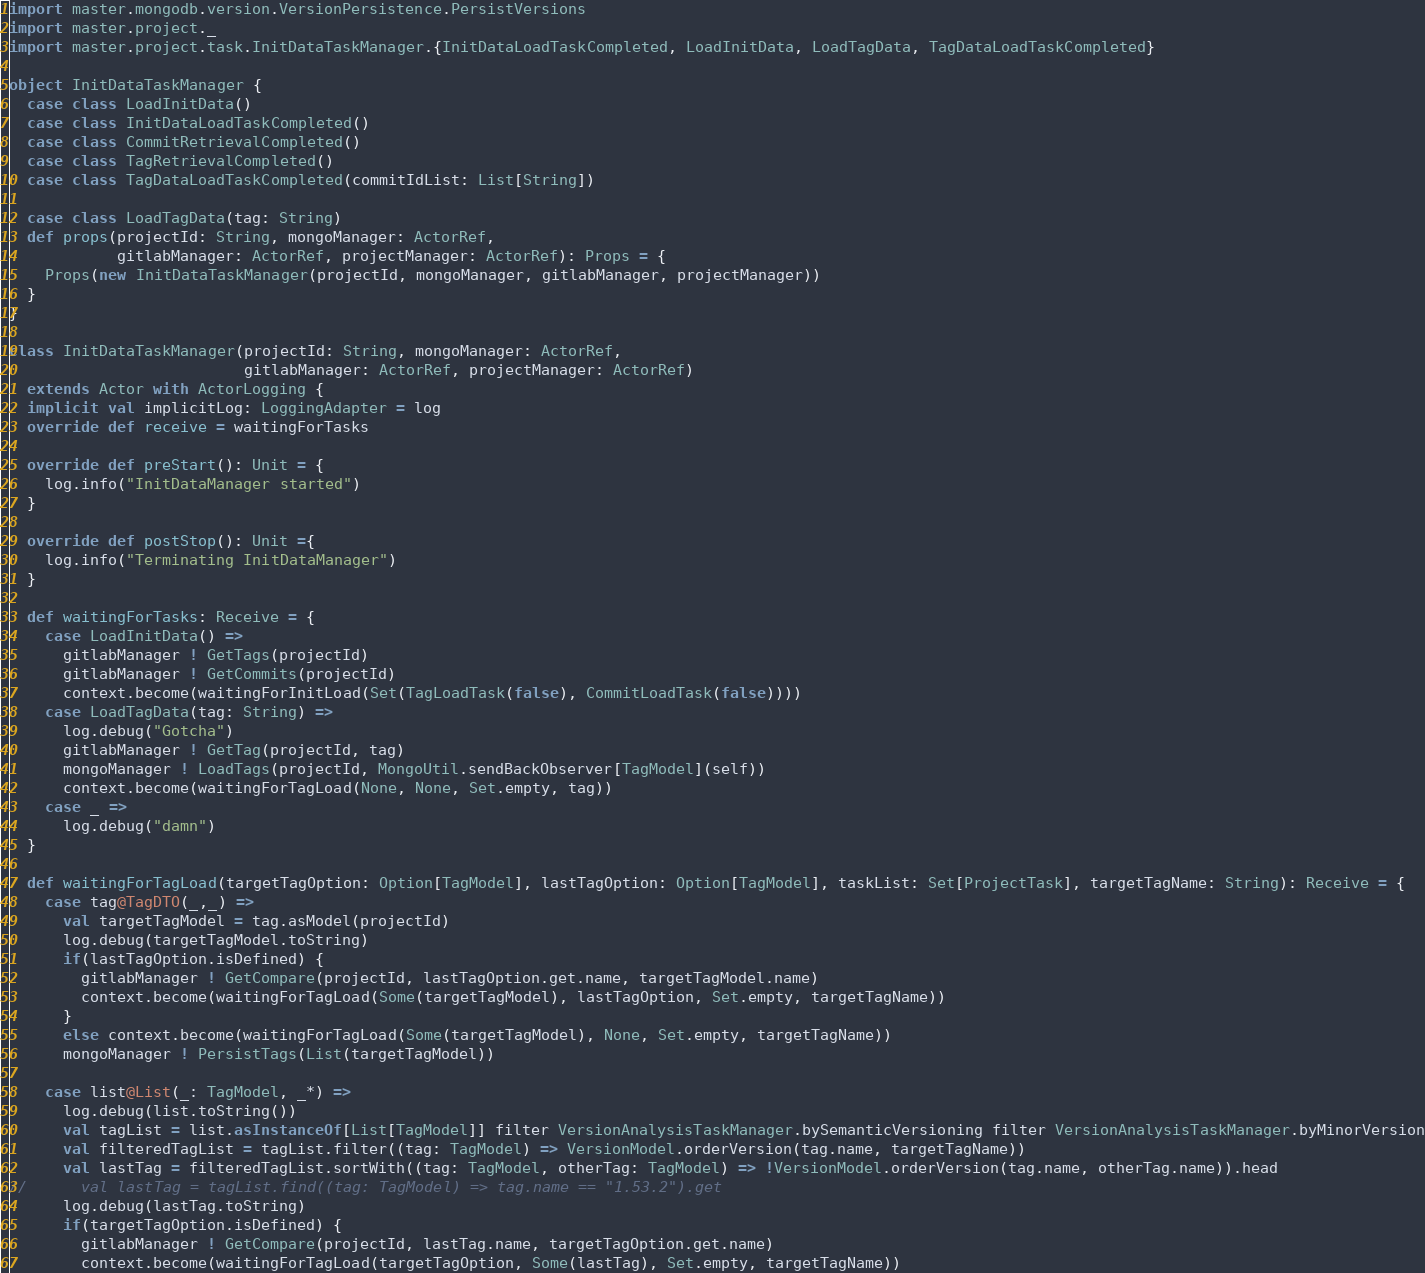Convert code to text. <code><loc_0><loc_0><loc_500><loc_500><_Scala_>import master.mongodb.version.VersionPersistence.PersistVersions
import master.project._
import master.project.task.InitDataTaskManager.{InitDataLoadTaskCompleted, LoadInitData, LoadTagData, TagDataLoadTaskCompleted}

object InitDataTaskManager {
  case class LoadInitData()
  case class InitDataLoadTaskCompleted()
  case class CommitRetrievalCompleted()
  case class TagRetrievalCompleted()
  case class TagDataLoadTaskCompleted(commitIdList: List[String])

  case class LoadTagData(tag: String)
  def props(projectId: String, mongoManager: ActorRef,
            gitlabManager: ActorRef, projectManager: ActorRef): Props = {
    Props(new InitDataTaskManager(projectId, mongoManager, gitlabManager, projectManager))
  }
}

class InitDataTaskManager(projectId: String, mongoManager: ActorRef,
                          gitlabManager: ActorRef, projectManager: ActorRef)
  extends Actor with ActorLogging {
  implicit val implicitLog: LoggingAdapter = log
  override def receive = waitingForTasks

  override def preStart(): Unit = {
    log.info("InitDataManager started")
  }

  override def postStop(): Unit ={
    log.info("Terminating InitDataManager")
  }

  def waitingForTasks: Receive = {
    case LoadInitData() =>
      gitlabManager ! GetTags(projectId)
      gitlabManager ! GetCommits(projectId)
      context.become(waitingForInitLoad(Set(TagLoadTask(false), CommitLoadTask(false))))
    case LoadTagData(tag: String) =>
      log.debug("Gotcha")
      gitlabManager ! GetTag(projectId, tag)
      mongoManager ! LoadTags(projectId, MongoUtil.sendBackObserver[TagModel](self))
      context.become(waitingForTagLoad(None, None, Set.empty, tag))
    case _ =>
      log.debug("damn")
  }

  def waitingForTagLoad(targetTagOption: Option[TagModel], lastTagOption: Option[TagModel], taskList: Set[ProjectTask], targetTagName: String): Receive = {
    case tag@TagDTO(_,_) =>
      val targetTagModel = tag.asModel(projectId)
      log.debug(targetTagModel.toString)
      if(lastTagOption.isDefined) {
        gitlabManager ! GetCompare(projectId, lastTagOption.get.name, targetTagModel.name)
        context.become(waitingForTagLoad(Some(targetTagModel), lastTagOption, Set.empty, targetTagName))
      }
      else context.become(waitingForTagLoad(Some(targetTagModel), None, Set.empty, targetTagName))
      mongoManager ! PersistTags(List(targetTagModel))

    case list@List(_: TagModel, _*) =>
      log.debug(list.toString())
      val tagList = list.asInstanceOf[List[TagModel]] filter VersionAnalysisTaskManager.bySemanticVersioning filter VersionAnalysisTaskManager.byMinorVersion
      val filteredTagList = tagList.filter((tag: TagModel) => VersionModel.orderVersion(tag.name, targetTagName))
      val lastTag = filteredTagList.sortWith((tag: TagModel, otherTag: TagModel) => !VersionModel.orderVersion(tag.name, otherTag.name)).head
//      val lastTag = tagList.find((tag: TagModel) => tag.name == "1.53.2").get
      log.debug(lastTag.toString)
      if(targetTagOption.isDefined) {
        gitlabManager ! GetCompare(projectId, lastTag.name, targetTagOption.get.name)
        context.become(waitingForTagLoad(targetTagOption, Some(lastTag), Set.empty, targetTagName))</code> 